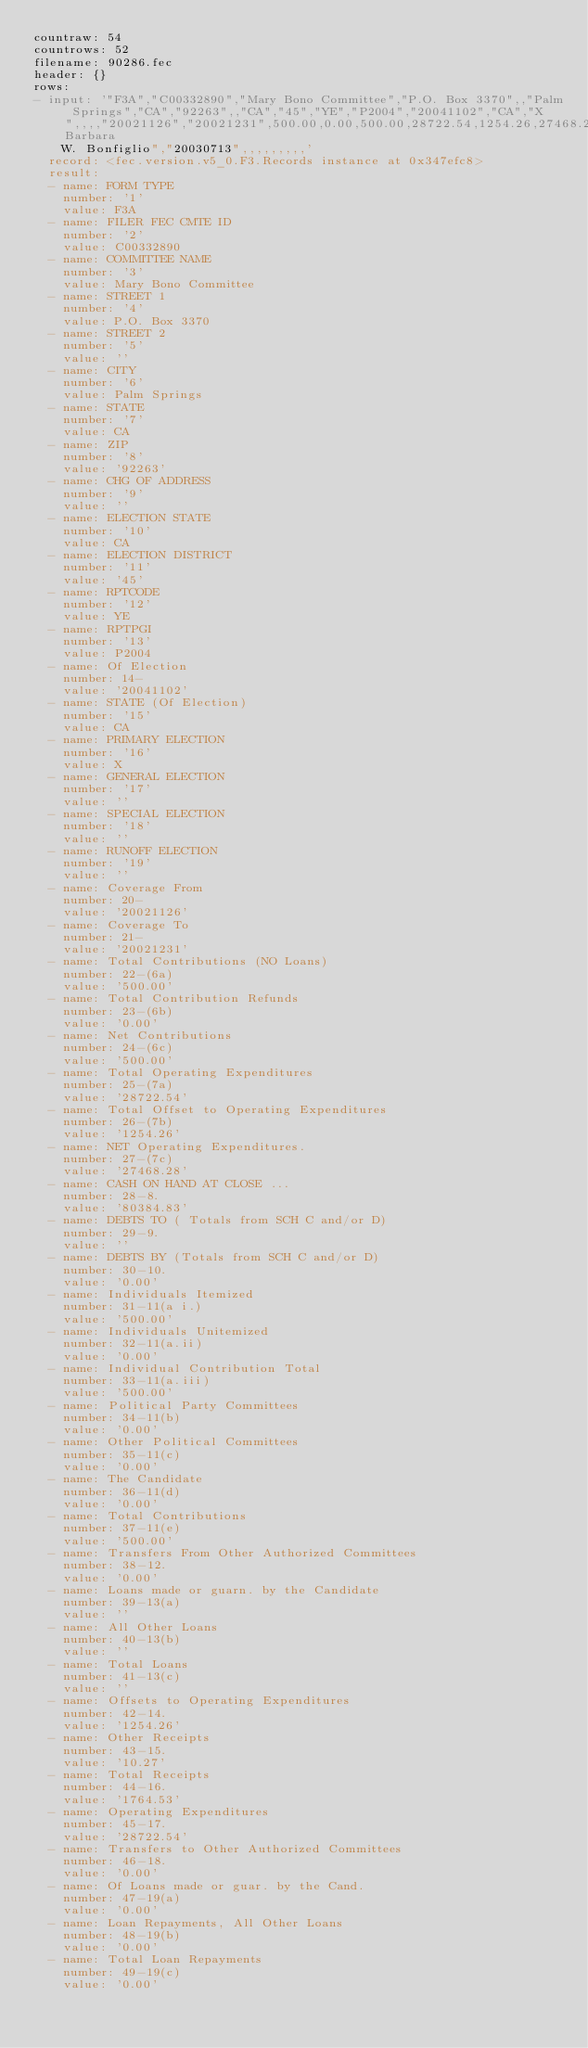<code> <loc_0><loc_0><loc_500><loc_500><_YAML_>countraw: 54
countrows: 52
filename: 90286.fec
header: {}
rows:
- input: '"F3A","C00332890","Mary Bono Committee","P.O. Box 3370",,"Palm Springs","CA","92263",,"CA","45","YE","P2004","20041102","CA","X",,,,"20021126","20021231",500.00,0.00,500.00,28722.54,1254.26,27468.28,80384.83,,0.00,500.00,0.00,500.00,0.00,0.00,0.00,500.00,0.00,,,,1254.26,10.27,1764.53,28722.54,0.00,0.00,0.00,0.00,0.00,0.00,0.00,0.00,0.00,28722.54,107342.84,1764.53,109107.37,28722.54,80384.83,8898.00,0.00,8898.00,47819.22,1789.13,46030.09,0.00,5398.00,5398.00,0.00,3500.00,0.00,8898.00,0.00,,,,1789.13,10.27,10697.40,47819.22,0.00,0.00,0.00,0.00,0.00,0.00,0.00,0.00,0.00,47819.22,"Barbara
    W. Bonfiglio","20030713",,,,,,,,,'
  record: <fec.version.v5_0.F3.Records instance at 0x347efc8>
  result:
  - name: FORM TYPE
    number: '1'
    value: F3A
  - name: FILER FEC CMTE ID
    number: '2'
    value: C00332890
  - name: COMMITTEE NAME
    number: '3'
    value: Mary Bono Committee
  - name: STREET 1
    number: '4'
    value: P.O. Box 3370
  - name: STREET 2
    number: '5'
    value: ''
  - name: CITY
    number: '6'
    value: Palm Springs
  - name: STATE
    number: '7'
    value: CA
  - name: ZIP
    number: '8'
    value: '92263'
  - name: CHG OF ADDRESS
    number: '9'
    value: ''
  - name: ELECTION STATE
    number: '10'
    value: CA
  - name: ELECTION DISTRICT
    number: '11'
    value: '45'
  - name: RPTCODE
    number: '12'
    value: YE
  - name: RPTPGI
    number: '13'
    value: P2004
  - name: Of Election
    number: 14-
    value: '20041102'
  - name: STATE (Of Election)
    number: '15'
    value: CA
  - name: PRIMARY ELECTION
    number: '16'
    value: X
  - name: GENERAL ELECTION
    number: '17'
    value: ''
  - name: SPECIAL ELECTION
    number: '18'
    value: ''
  - name: RUNOFF ELECTION
    number: '19'
    value: ''
  - name: Coverage From
    number: 20-
    value: '20021126'
  - name: Coverage To
    number: 21-
    value: '20021231'
  - name: Total Contributions (NO Loans)
    number: 22-(6a)
    value: '500.00'
  - name: Total Contribution Refunds
    number: 23-(6b)
    value: '0.00'
  - name: Net Contributions
    number: 24-(6c)
    value: '500.00'
  - name: Total Operating Expenditures
    number: 25-(7a)
    value: '28722.54'
  - name: Total Offset to Operating Expenditures
    number: 26-(7b)
    value: '1254.26'
  - name: NET Operating Expenditures.
    number: 27-(7c)
    value: '27468.28'
  - name: CASH ON HAND AT CLOSE ...
    number: 28-8.
    value: '80384.83'
  - name: DEBTS TO ( Totals from SCH C and/or D)
    number: 29-9.
    value: ''
  - name: DEBTS BY (Totals from SCH C and/or D)
    number: 30-10.
    value: '0.00'
  - name: Individuals Itemized
    number: 31-11(a i.)
    value: '500.00'
  - name: Individuals Unitemized
    number: 32-11(a.ii)
    value: '0.00'
  - name: Individual Contribution Total
    number: 33-11(a.iii)
    value: '500.00'
  - name: Political Party Committees
    number: 34-11(b)
    value: '0.00'
  - name: Other Political Committees
    number: 35-11(c)
    value: '0.00'
  - name: The Candidate
    number: 36-11(d)
    value: '0.00'
  - name: Total Contributions
    number: 37-11(e)
    value: '500.00'
  - name: Transfers From Other Authorized Committees
    number: 38-12.
    value: '0.00'
  - name: Loans made or guarn. by the Candidate
    number: 39-13(a)
    value: ''
  - name: All Other Loans
    number: 40-13(b)
    value: ''
  - name: Total Loans
    number: 41-13(c)
    value: ''
  - name: Offsets to Operating Expenditures
    number: 42-14.
    value: '1254.26'
  - name: Other Receipts
    number: 43-15.
    value: '10.27'
  - name: Total Receipts
    number: 44-16.
    value: '1764.53'
  - name: Operating Expenditures
    number: 45-17.
    value: '28722.54'
  - name: Transfers to Other Authorized Committees
    number: 46-18.
    value: '0.00'
  - name: Of Loans made or guar. by the Cand.
    number: 47-19(a)
    value: '0.00'
  - name: Loan Repayments, All Other Loans
    number: 48-19(b)
    value: '0.00'
  - name: Total Loan Repayments
    number: 49-19(c)
    value: '0.00'</code> 